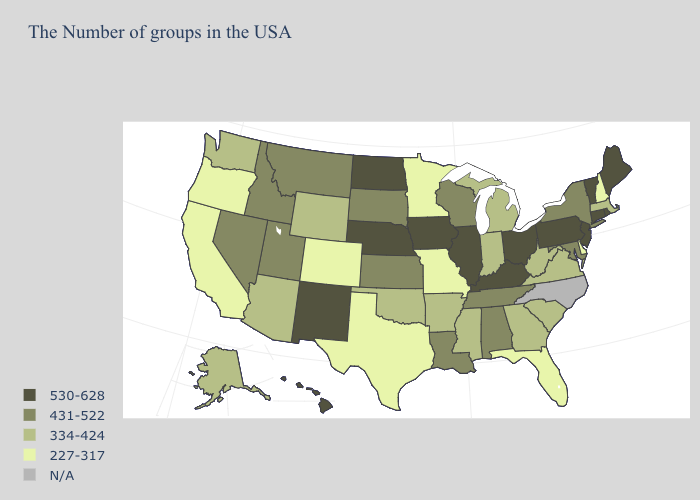Name the states that have a value in the range 334-424?
Give a very brief answer. Massachusetts, Virginia, South Carolina, West Virginia, Georgia, Michigan, Indiana, Mississippi, Arkansas, Oklahoma, Wyoming, Arizona, Washington, Alaska. Which states have the lowest value in the USA?
Short answer required. New Hampshire, Delaware, Florida, Missouri, Minnesota, Texas, Colorado, California, Oregon. Does New Mexico have the lowest value in the West?
Give a very brief answer. No. Which states have the highest value in the USA?
Quick response, please. Maine, Rhode Island, Vermont, Connecticut, New Jersey, Pennsylvania, Ohio, Kentucky, Illinois, Iowa, Nebraska, North Dakota, New Mexico, Hawaii. Which states have the lowest value in the USA?
Write a very short answer. New Hampshire, Delaware, Florida, Missouri, Minnesota, Texas, Colorado, California, Oregon. Which states have the lowest value in the MidWest?
Concise answer only. Missouri, Minnesota. Does Kentucky have the highest value in the South?
Quick response, please. Yes. Among the states that border Louisiana , which have the highest value?
Quick response, please. Mississippi, Arkansas. Name the states that have a value in the range 431-522?
Be succinct. New York, Maryland, Alabama, Tennessee, Wisconsin, Louisiana, Kansas, South Dakota, Utah, Montana, Idaho, Nevada. What is the value of Alaska?
Short answer required. 334-424. What is the highest value in states that border Virginia?
Answer briefly. 530-628. What is the value of Rhode Island?
Give a very brief answer. 530-628. Which states have the lowest value in the West?
Write a very short answer. Colorado, California, Oregon. What is the value of Illinois?
Keep it brief. 530-628. 